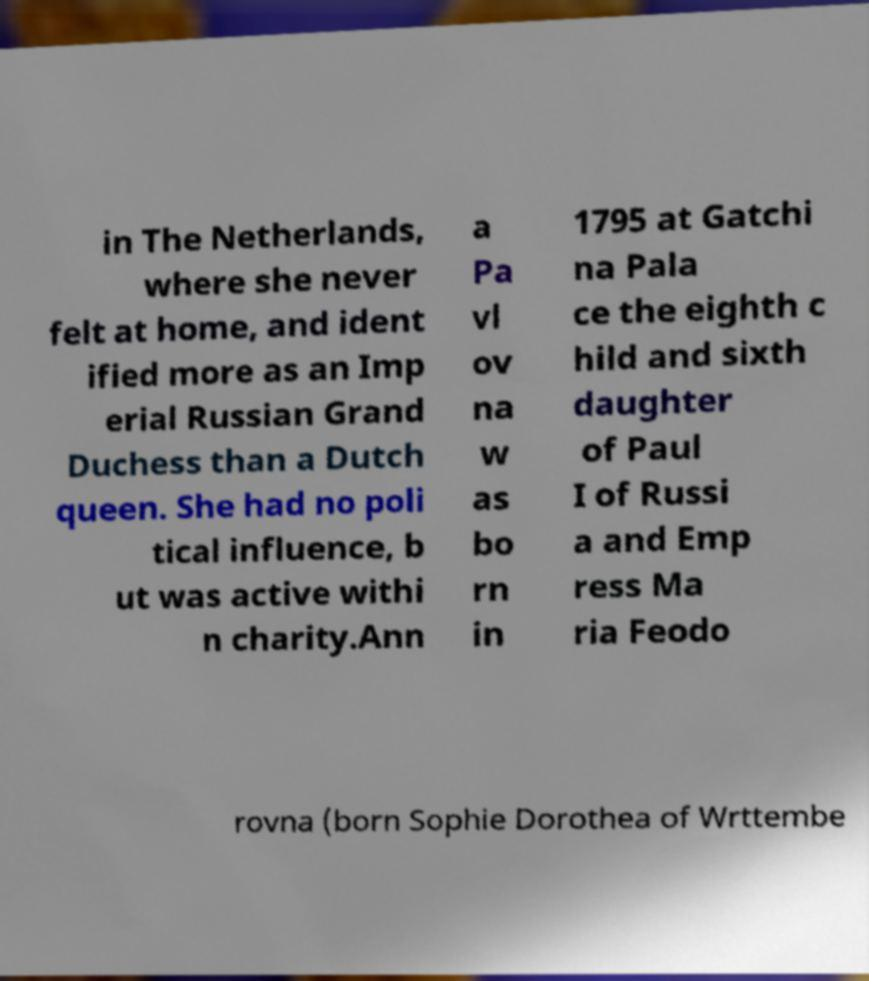There's text embedded in this image that I need extracted. Can you transcribe it verbatim? in The Netherlands, where she never felt at home, and ident ified more as an Imp erial Russian Grand Duchess than a Dutch queen. She had no poli tical influence, b ut was active withi n charity.Ann a Pa vl ov na w as bo rn in 1795 at Gatchi na Pala ce the eighth c hild and sixth daughter of Paul I of Russi a and Emp ress Ma ria Feodo rovna (born Sophie Dorothea of Wrttembe 